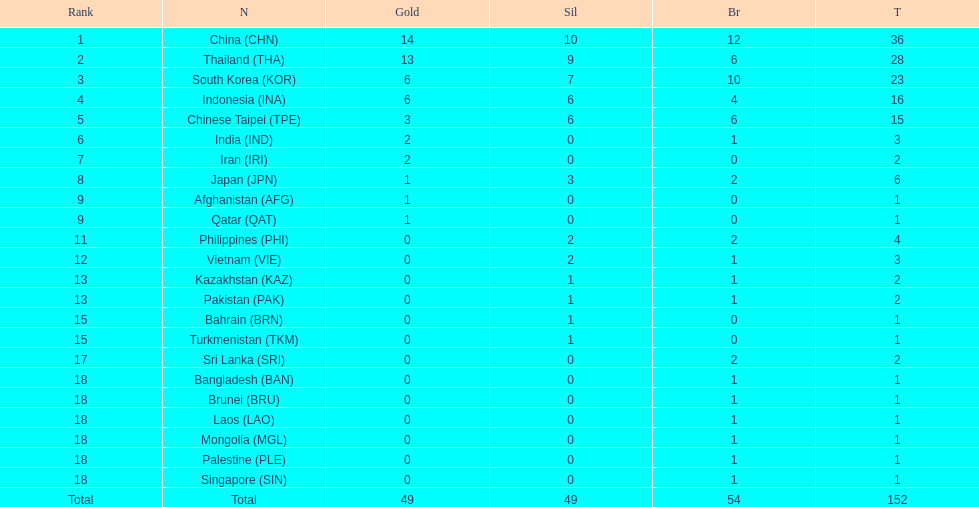Can you parse all the data within this table? {'header': ['Rank', 'N', 'Gold', 'Sil', 'Br', 'T'], 'rows': [['1', 'China\xa0(CHN)', '14', '10', '12', '36'], ['2', 'Thailand\xa0(THA)', '13', '9', '6', '28'], ['3', 'South Korea\xa0(KOR)', '6', '7', '10', '23'], ['4', 'Indonesia\xa0(INA)', '6', '6', '4', '16'], ['5', 'Chinese Taipei\xa0(TPE)', '3', '6', '6', '15'], ['6', 'India\xa0(IND)', '2', '0', '1', '3'], ['7', 'Iran\xa0(IRI)', '2', '0', '0', '2'], ['8', 'Japan\xa0(JPN)', '1', '3', '2', '6'], ['9', 'Afghanistan\xa0(AFG)', '1', '0', '0', '1'], ['9', 'Qatar\xa0(QAT)', '1', '0', '0', '1'], ['11', 'Philippines\xa0(PHI)', '0', '2', '2', '4'], ['12', 'Vietnam\xa0(VIE)', '0', '2', '1', '3'], ['13', 'Kazakhstan\xa0(KAZ)', '0', '1', '1', '2'], ['13', 'Pakistan\xa0(PAK)', '0', '1', '1', '2'], ['15', 'Bahrain\xa0(BRN)', '0', '1', '0', '1'], ['15', 'Turkmenistan\xa0(TKM)', '0', '1', '0', '1'], ['17', 'Sri Lanka\xa0(SRI)', '0', '0', '2', '2'], ['18', 'Bangladesh\xa0(BAN)', '0', '0', '1', '1'], ['18', 'Brunei\xa0(BRU)', '0', '0', '1', '1'], ['18', 'Laos\xa0(LAO)', '0', '0', '1', '1'], ['18', 'Mongolia\xa0(MGL)', '0', '0', '1', '1'], ['18', 'Palestine\xa0(PLE)', '0', '0', '1', '1'], ['18', 'Singapore\xa0(SIN)', '0', '0', '1', '1'], ['Total', 'Total', '49', '49', '54', '152']]} Which nation finished first in total medals earned? China (CHN). 